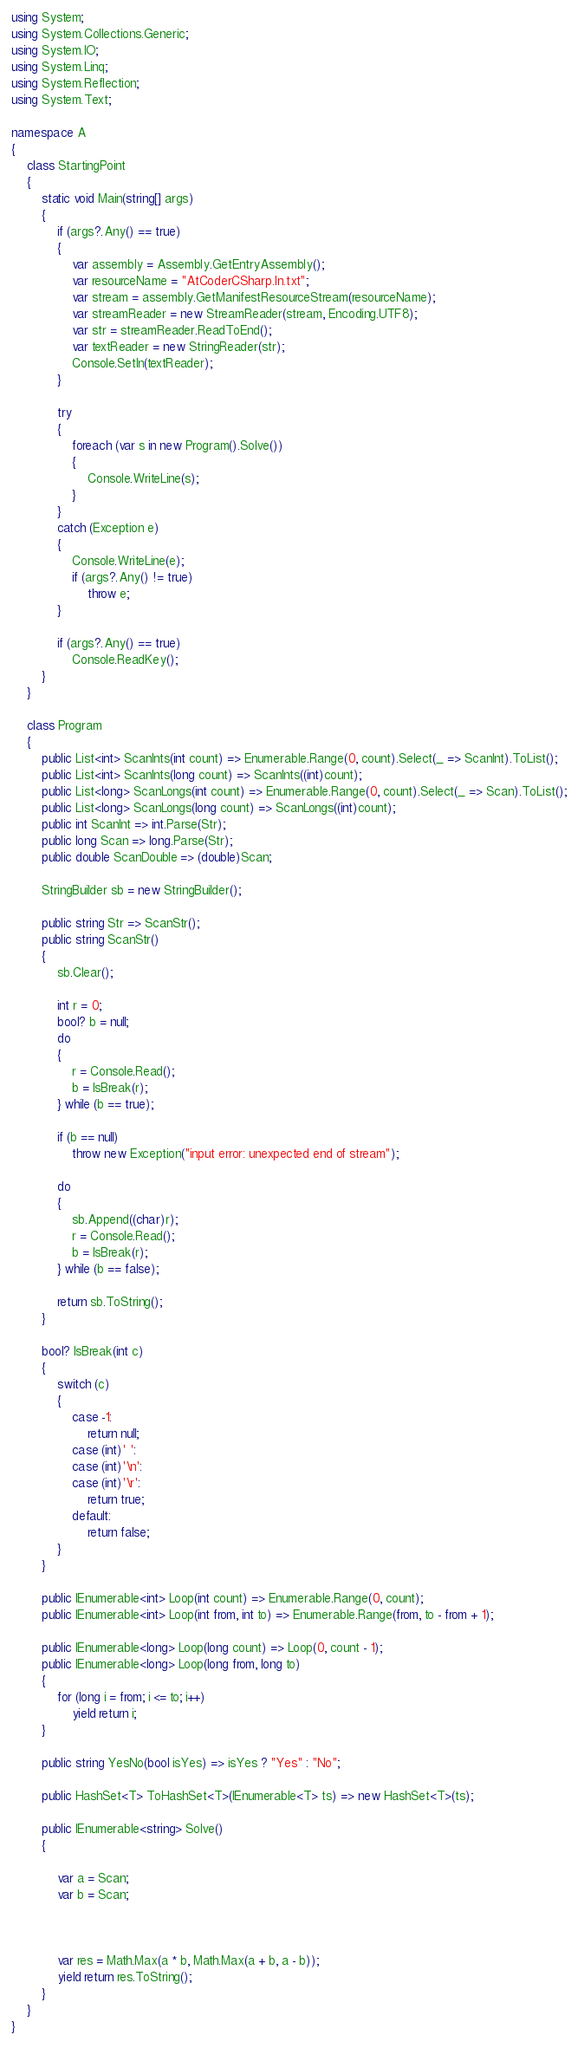<code> <loc_0><loc_0><loc_500><loc_500><_C#_>using System;
using System.Collections.Generic;
using System.IO;
using System.Linq;
using System.Reflection;
using System.Text;

namespace A
{
    class StartingPoint
    {
        static void Main(string[] args)
        {
            if (args?.Any() == true)
            {
                var assembly = Assembly.GetEntryAssembly();
                var resourceName = "AtCoderCSharp.In.txt";
                var stream = assembly.GetManifestResourceStream(resourceName);
                var streamReader = new StreamReader(stream, Encoding.UTF8);
                var str = streamReader.ReadToEnd();
                var textReader = new StringReader(str);
                Console.SetIn(textReader);
            }

            try
            {
                foreach (var s in new Program().Solve())
                {
                    Console.WriteLine(s);
                }
            }
            catch (Exception e)
            {
                Console.WriteLine(e);
                if (args?.Any() != true)
                    throw e;
            }

            if (args?.Any() == true)
                Console.ReadKey();
        }
    }

    class Program
    {
        public List<int> ScanInts(int count) => Enumerable.Range(0, count).Select(_ => ScanInt).ToList();
        public List<int> ScanInts(long count) => ScanInts((int)count);
        public List<long> ScanLongs(int count) => Enumerable.Range(0, count).Select(_ => Scan).ToList();
        public List<long> ScanLongs(long count) => ScanLongs((int)count);
        public int ScanInt => int.Parse(Str);
        public long Scan => long.Parse(Str);
        public double ScanDouble => (double)Scan;

        StringBuilder sb = new StringBuilder();

        public string Str => ScanStr();
        public string ScanStr()
        {
            sb.Clear();

            int r = 0;
            bool? b = null;
            do
            {
                r = Console.Read();
                b = IsBreak(r);
            } while (b == true);

            if (b == null)
                throw new Exception("input error: unexpected end of stream");

            do
            {
                sb.Append((char)r);
                r = Console.Read();
                b = IsBreak(r);
            } while (b == false);

            return sb.ToString();
        }

        bool? IsBreak(int c)
        {
            switch (c)
            {
                case -1:
                    return null;
                case (int)' ':
                case (int)'\n':
                case (int)'\r':
                    return true;
                default:
                    return false;
            }
        }

        public IEnumerable<int> Loop(int count) => Enumerable.Range(0, count);
        public IEnumerable<int> Loop(int from, int to) => Enumerable.Range(from, to - from + 1);

        public IEnumerable<long> Loop(long count) => Loop(0, count - 1);
        public IEnumerable<long> Loop(long from, long to)
        {
            for (long i = from; i <= to; i++)
                yield return i;
        }

        public string YesNo(bool isYes) => isYes ? "Yes" : "No";

        public HashSet<T> ToHashSet<T>(IEnumerable<T> ts) => new HashSet<T>(ts);

        public IEnumerable<string> Solve()
        {

            var a = Scan;
            var b = Scan;



            var res = Math.Max(a * b, Math.Max(a + b, a - b));
            yield return res.ToString();
        }
    }
}</code> 